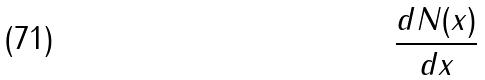Convert formula to latex. <formula><loc_0><loc_0><loc_500><loc_500>\frac { d N ( x ) } { d x }</formula> 